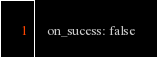Convert code to text. <code><loc_0><loc_0><loc_500><loc_500><_YAML_>    on_sucess: false
</code> 